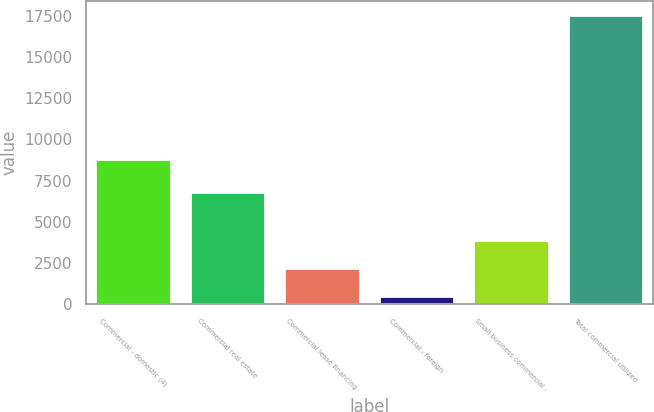Convert chart. <chart><loc_0><loc_0><loc_500><loc_500><bar_chart><fcel>Commercial - domestic (4)<fcel>Commercial real estate<fcel>Commercial lease financing<fcel>Commercial - foreign<fcel>Small business commercial -<fcel>Total commercial utilized<nl><fcel>8829<fcel>6825<fcel>2213.4<fcel>509<fcel>3917.8<fcel>17553<nl></chart> 